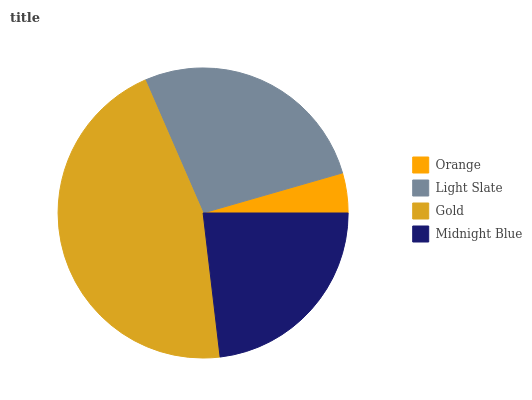Is Orange the minimum?
Answer yes or no. Yes. Is Gold the maximum?
Answer yes or no. Yes. Is Light Slate the minimum?
Answer yes or no. No. Is Light Slate the maximum?
Answer yes or no. No. Is Light Slate greater than Orange?
Answer yes or no. Yes. Is Orange less than Light Slate?
Answer yes or no. Yes. Is Orange greater than Light Slate?
Answer yes or no. No. Is Light Slate less than Orange?
Answer yes or no. No. Is Light Slate the high median?
Answer yes or no. Yes. Is Midnight Blue the low median?
Answer yes or no. Yes. Is Midnight Blue the high median?
Answer yes or no. No. Is Light Slate the low median?
Answer yes or no. No. 